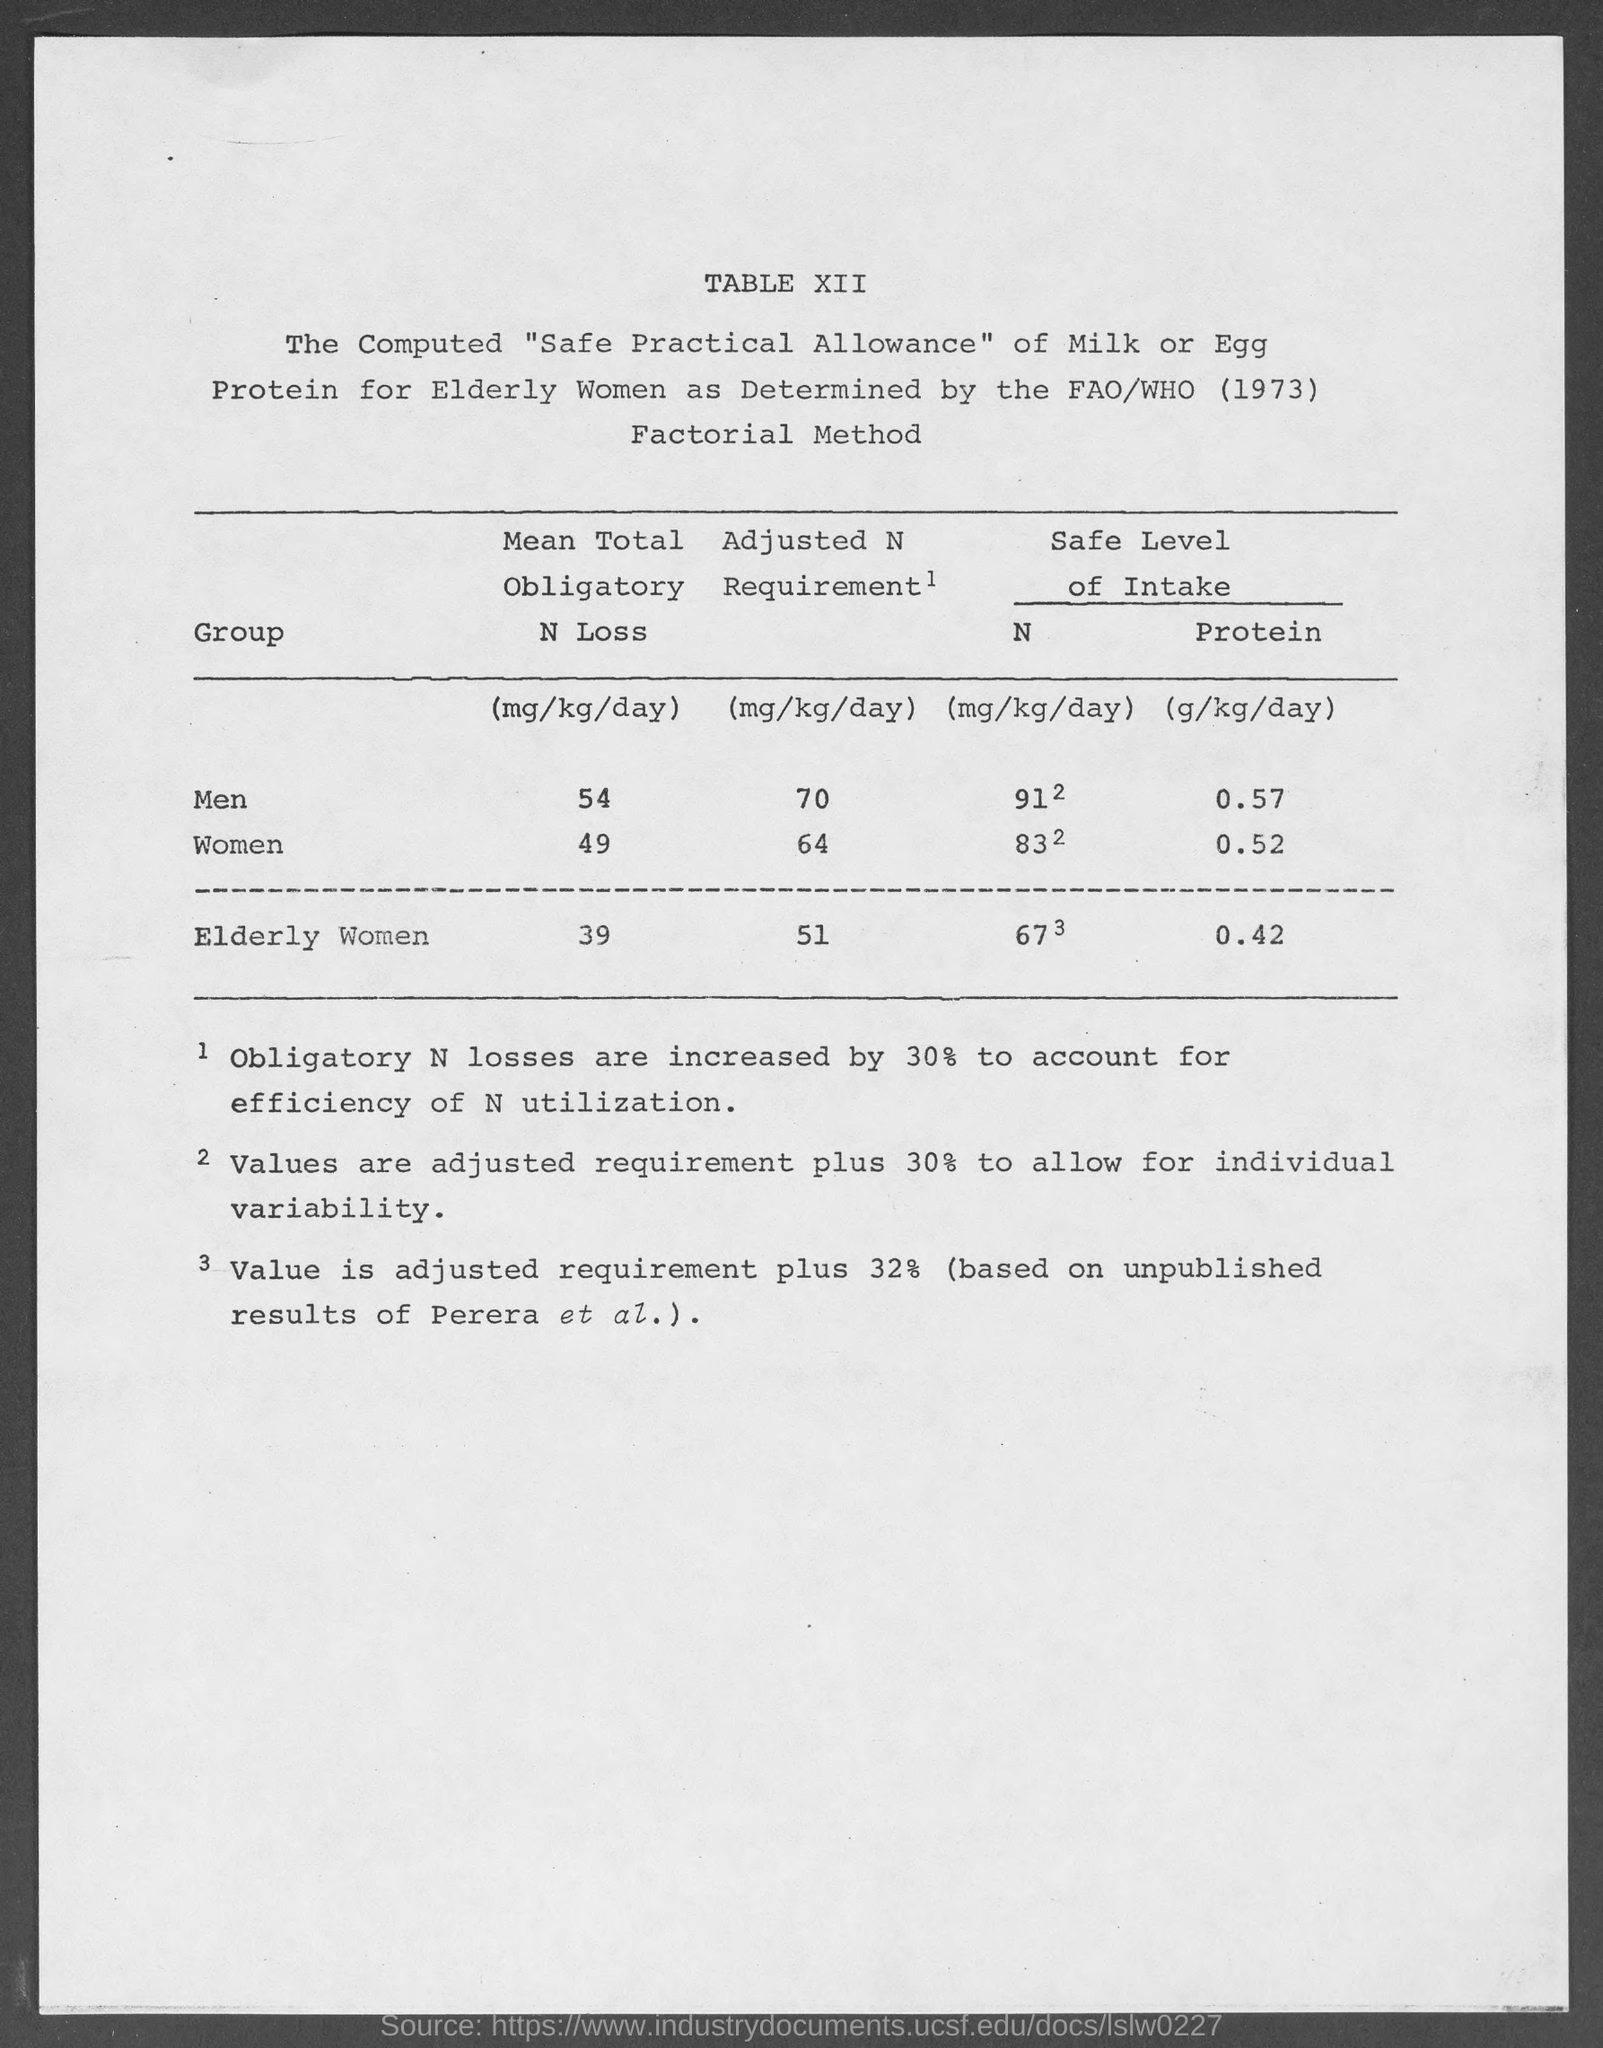Mention a couple of crucial points in this snapshot. The value of mean total obligatory N loss in men, as mentioned in the given table, is 54. The value of mean total obligatory N loss in women, as mentioned in the given table, is 49. The method mentioned on the given page is called the factorial method. The safe level intake of protein for women, as mentioned in the given table, is 0.52 grams per kilogram of body weight per day. The safe intake of protein for elderly women, as stated in the provided table, is 0.42 grams per kilogram of body weight per day. 